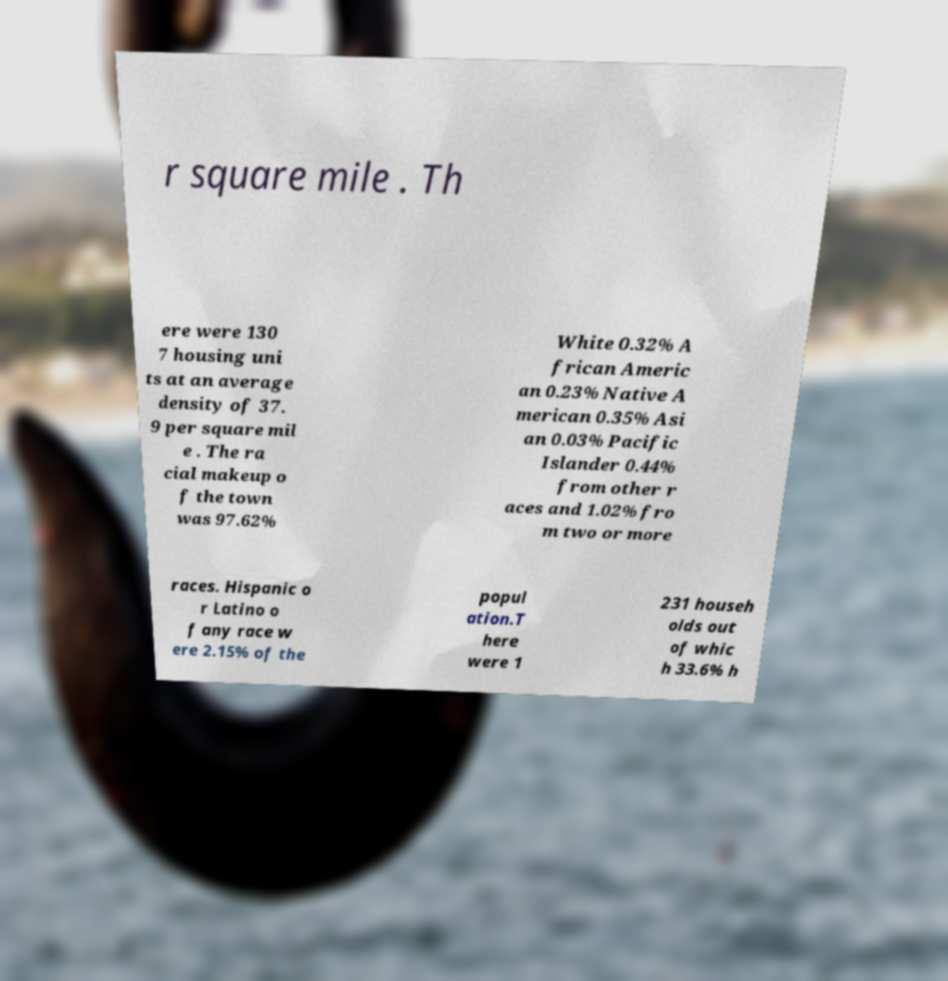Could you assist in decoding the text presented in this image and type it out clearly? r square mile . Th ere were 130 7 housing uni ts at an average density of 37. 9 per square mil e . The ra cial makeup o f the town was 97.62% White 0.32% A frican Americ an 0.23% Native A merican 0.35% Asi an 0.03% Pacific Islander 0.44% from other r aces and 1.02% fro m two or more races. Hispanic o r Latino o f any race w ere 2.15% of the popul ation.T here were 1 231 househ olds out of whic h 33.6% h 